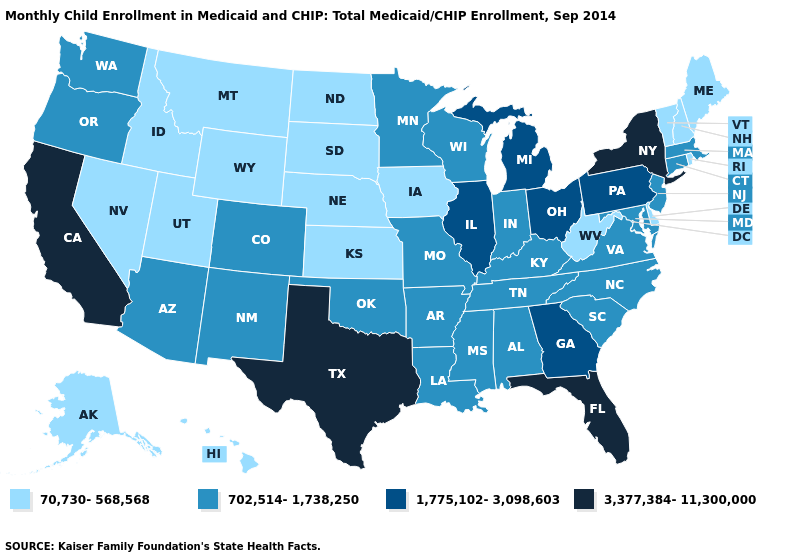Among the states that border Michigan , does Ohio have the highest value?
Concise answer only. Yes. Name the states that have a value in the range 70,730-568,568?
Give a very brief answer. Alaska, Delaware, Hawaii, Idaho, Iowa, Kansas, Maine, Montana, Nebraska, Nevada, New Hampshire, North Dakota, Rhode Island, South Dakota, Utah, Vermont, West Virginia, Wyoming. What is the highest value in states that border Oklahoma?
Give a very brief answer. 3,377,384-11,300,000. Among the states that border Missouri , which have the lowest value?
Answer briefly. Iowa, Kansas, Nebraska. Among the states that border Arkansas , does Texas have the highest value?
Quick response, please. Yes. Which states hav the highest value in the South?
Short answer required. Florida, Texas. Does Arizona have a lower value than California?
Short answer required. Yes. Does the first symbol in the legend represent the smallest category?
Concise answer only. Yes. Name the states that have a value in the range 70,730-568,568?
Short answer required. Alaska, Delaware, Hawaii, Idaho, Iowa, Kansas, Maine, Montana, Nebraska, Nevada, New Hampshire, North Dakota, Rhode Island, South Dakota, Utah, Vermont, West Virginia, Wyoming. Does New York have the highest value in the USA?
Concise answer only. Yes. Name the states that have a value in the range 702,514-1,738,250?
Keep it brief. Alabama, Arizona, Arkansas, Colorado, Connecticut, Indiana, Kentucky, Louisiana, Maryland, Massachusetts, Minnesota, Mississippi, Missouri, New Jersey, New Mexico, North Carolina, Oklahoma, Oregon, South Carolina, Tennessee, Virginia, Washington, Wisconsin. Name the states that have a value in the range 702,514-1,738,250?
Write a very short answer. Alabama, Arizona, Arkansas, Colorado, Connecticut, Indiana, Kentucky, Louisiana, Maryland, Massachusetts, Minnesota, Mississippi, Missouri, New Jersey, New Mexico, North Carolina, Oklahoma, Oregon, South Carolina, Tennessee, Virginia, Washington, Wisconsin. Is the legend a continuous bar?
Concise answer only. No. Among the states that border North Carolina , does Virginia have the highest value?
Quick response, please. No. Does Colorado have the lowest value in the West?
Be succinct. No. 